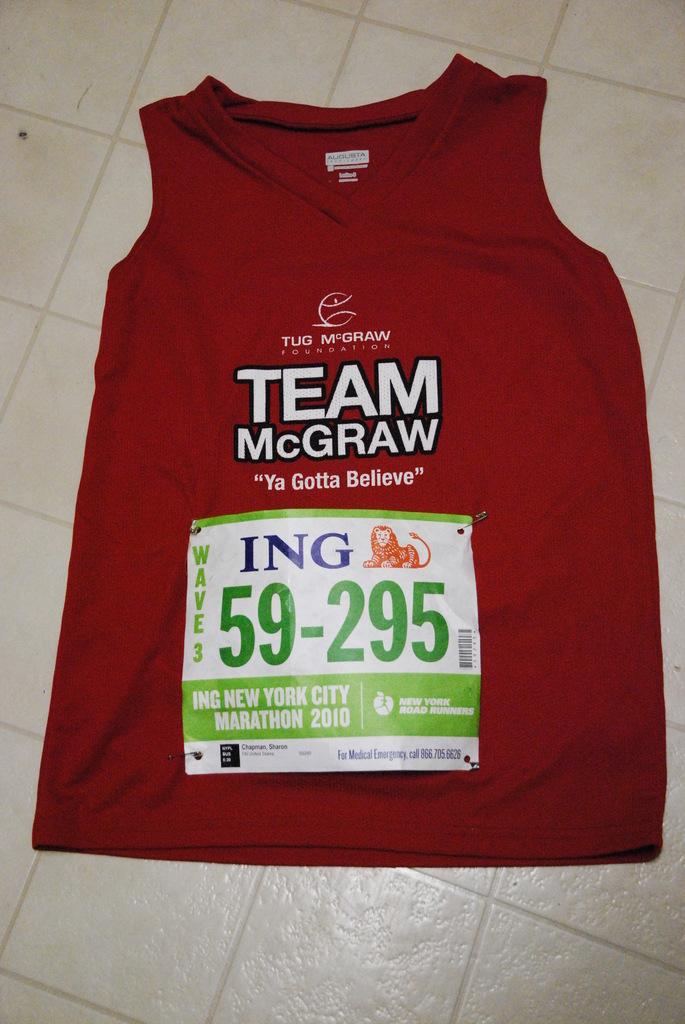What number is on this shirt?
Ensure brevity in your answer.  59-295. 